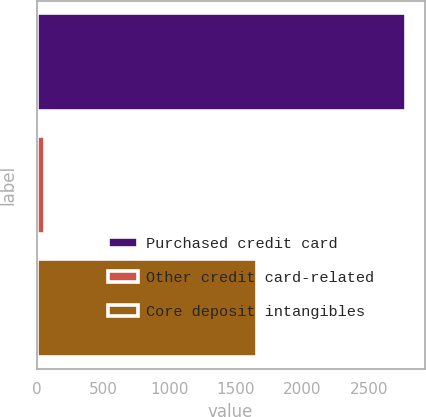<chart> <loc_0><loc_0><loc_500><loc_500><bar_chart><fcel>Purchased credit card<fcel>Other credit card-related<fcel>Core deposit intangibles<nl><fcel>2781<fcel>65<fcel>1660<nl></chart> 